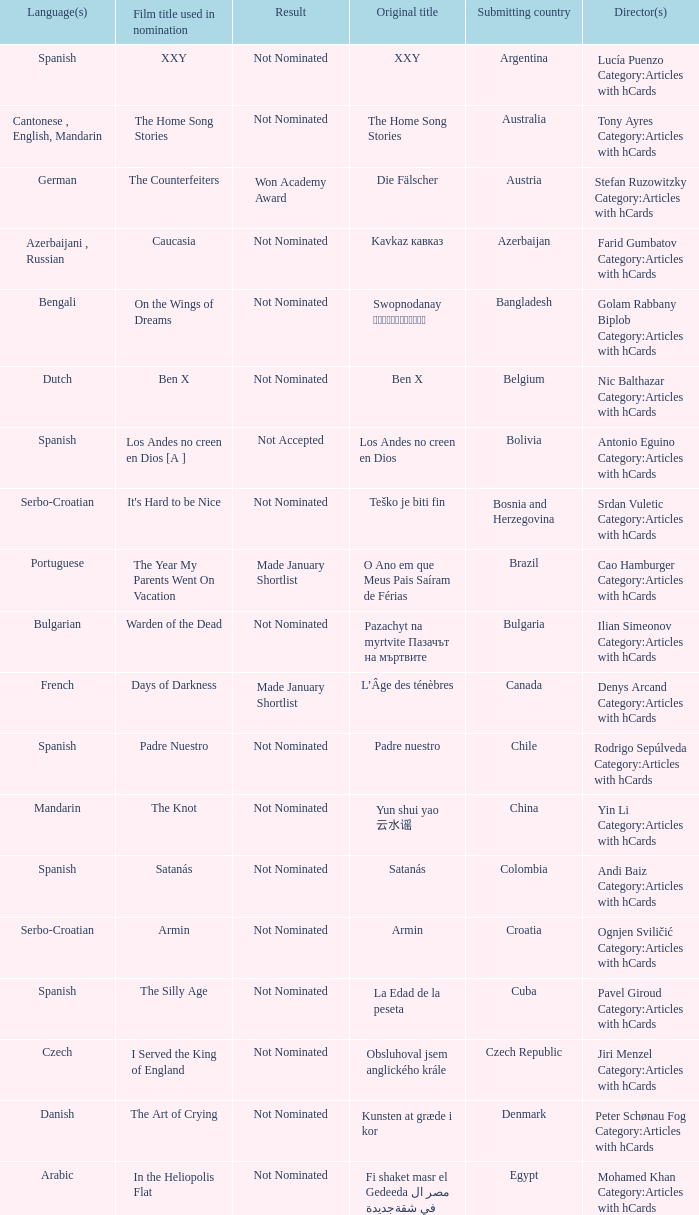What country submitted miehen työ? Finland. 